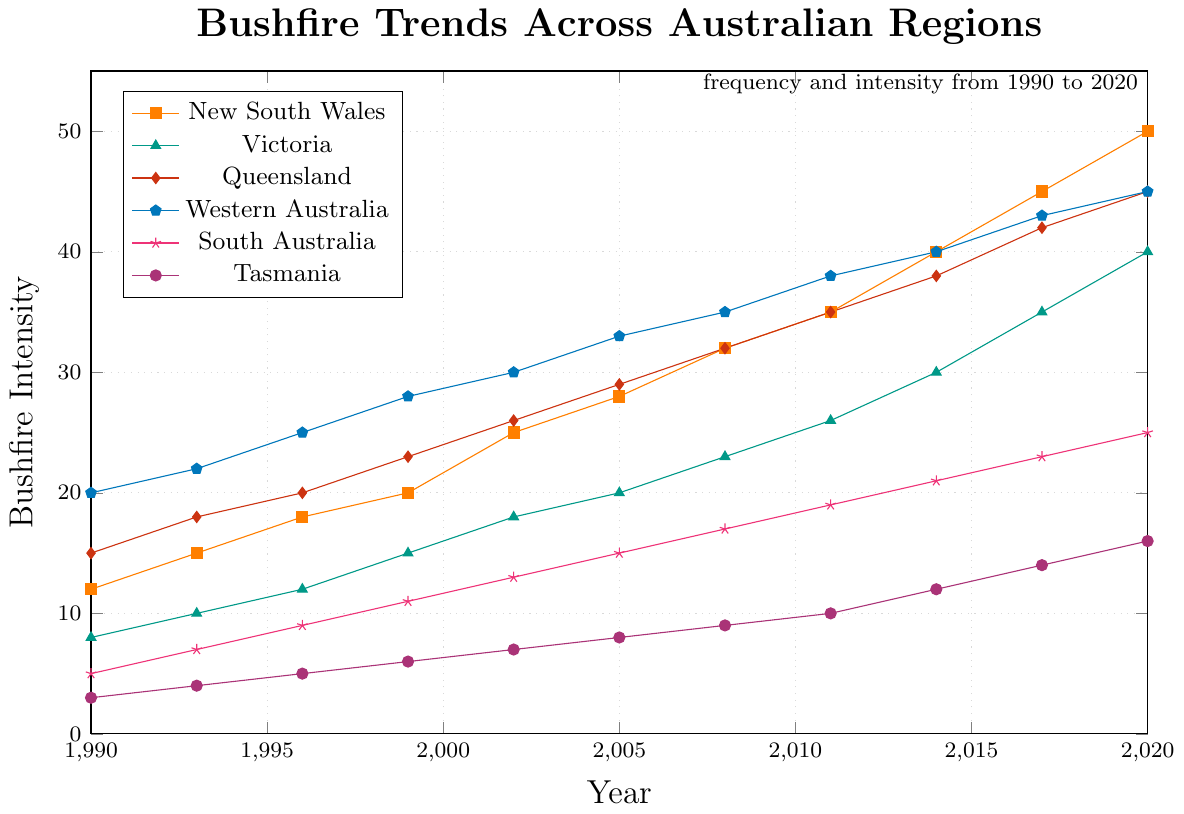What is the overall trend in bushfire intensity in New South Wales from 1990 to 2020? Look at the line representing New South Wales, which is marked with square markers. The bushfire intensity starts at 12 in 1990 and increases to 50 in 2020, indicating a rising trend.
Answer: Rising Which region had the highest bushfire intensity in 2020? To determine this, check the values at 2020 across all the regions. New South Wales has the highest bushfire intensity with a value of 50 in 2020.
Answer: New South Wales What is the difference in bushfire intensity between Victoria and Tasmania in 2014? Look at the values for Victoria and Tasmania in 2014. Victoria has an intensity of 30, and Tasmania has an intensity of 12. The difference is calculated as 30 - 12 = 18.
Answer: 18 Which regions show a steady increase in bushfire intensity without any decline from 1990 to 2020? Inspect each region's line plot for a consistent upward trend without any dips. New South Wales, Victoria, Queensland, Western Australia, South Australia, and Tasmania all show a steady increase.
Answer: New South Wales, Victoria, Queensland, Western Australia, South Australia, Tasmania What is the average bushfire intensity in Western Australia across the three decades? The values for Western Australia from 1990 to 2020 are: 20, 22, 25, 28, 30, 33, 35, 38, 40, 43, and 45. Sum these values (20 + 22 + 25 + 28 + 30 + 33 + 35 + 38 + 40 + 43 + 45 = 359). There are 11 values, so the average is 359 / 11 ≈ 32.64.
Answer: Approximately 32.64 In which year did South Australia's bushfire intensity reach 15? Look at the plot for South Australia, which is marked with a star. Trace the line to find the year where the value reaches 15. It occurred in 2005.
Answer: 2005 How does the bushfire intensity in Queensland compare to that in Tasmania in 1996? Check the values for Queensland and Tasmania in 1996. Queensland has a value of 20, and Tasmania has a value of 5. Queensland’s intensity is higher.
Answer: Queensland is higher By how much did the bushfire intensity in New South Wales increase from 1990 to 2002? The intensity in New South Wales in 1990 was 12, and in 2002 it was 25. The increase is calculated as 25 - 12 = 13.
Answer: 13 Which year saw the highest increase in bushfire intensity for Victoria within the given period? Calculate the differences between consecutive years for Victoria’s intensity values. The maximum difference occurs between 2017 and 2020 (40 - 35 = 5). Therefore, 2020 saw the highest increase.
Answer: 2020 Have there been any overlapping bushfire intensity values among Western Australia and Queensland between 1990 and 2020? Compare the values year by year for Western Australia and Queensland. The values overlap in 2017 and 2020, where both regions have bushfire intensity values of 43 and 45 respectively.
Answer: Yes, in 2017 and 2020 